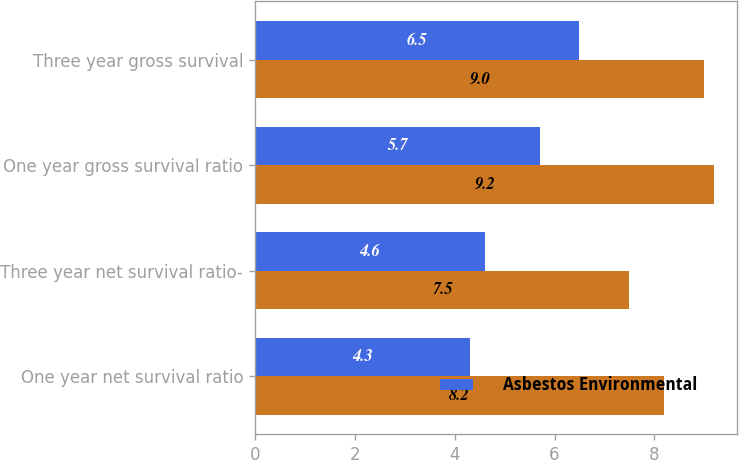<chart> <loc_0><loc_0><loc_500><loc_500><stacked_bar_chart><ecel><fcel>One year net survival ratio<fcel>Three year net survival ratio-<fcel>One year gross survival ratio<fcel>Three year gross survival<nl><fcel>nan<fcel>8.2<fcel>7.5<fcel>9.2<fcel>9<nl><fcel>Asbestos Environmental<fcel>4.3<fcel>4.6<fcel>5.7<fcel>6.5<nl></chart> 